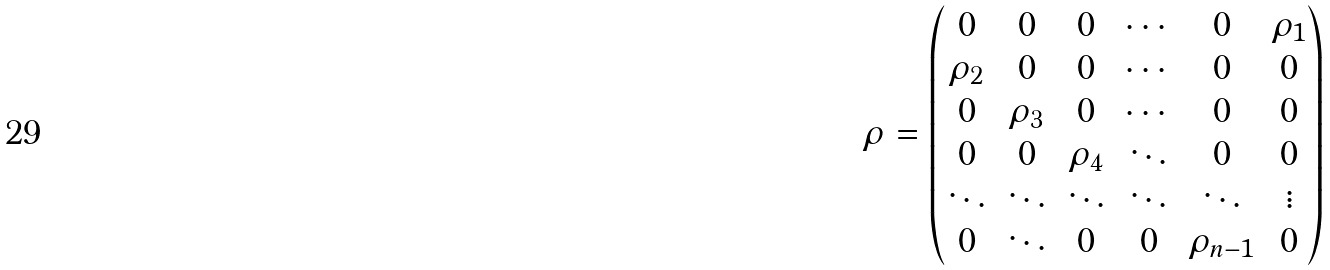<formula> <loc_0><loc_0><loc_500><loc_500>\rho = \begin{pmatrix} 0 & 0 & 0 & \cdots & 0 & \rho _ { 1 } \\ \rho _ { 2 } & 0 & 0 & \cdots & 0 & 0 \\ 0 & \rho _ { 3 } & 0 & \cdots & 0 & 0 \\ 0 & 0 & \rho _ { 4 } & \ddots & 0 & 0 \\ \ddots & \ddots & \ddots & \ddots & \ddots & \vdots \\ 0 & \ddots & 0 & 0 & \rho _ { n - 1 } & 0 \\ \end{pmatrix}</formula> 